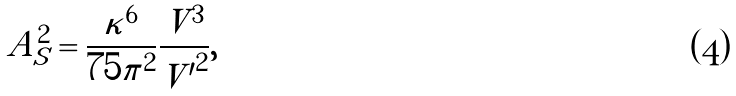Convert formula to latex. <formula><loc_0><loc_0><loc_500><loc_500>A _ { S } ^ { 2 } = \frac { \kappa ^ { 6 } } { 7 5 \pi ^ { 2 } } \frac { V ^ { 3 } } { { V ^ { \prime } } ^ { 2 } } ,</formula> 